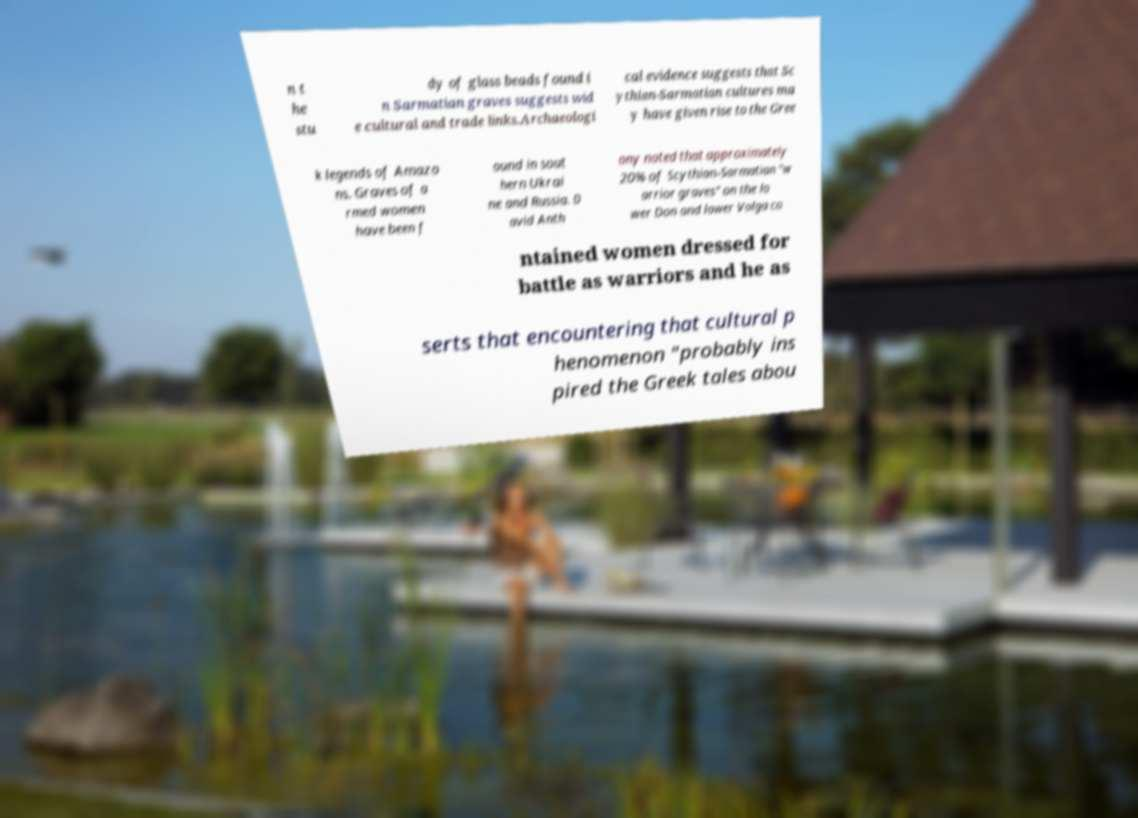There's text embedded in this image that I need extracted. Can you transcribe it verbatim? n t he stu dy of glass beads found i n Sarmatian graves suggests wid e cultural and trade links.Archaeologi cal evidence suggests that Sc ythian-Sarmatian cultures ma y have given rise to the Gree k legends of Amazo ns. Graves of a rmed women have been f ound in sout hern Ukrai ne and Russia. D avid Anth ony noted that approximately 20% of Scythian-Sarmatian "w arrior graves" on the lo wer Don and lower Volga co ntained women dressed for battle as warriors and he as serts that encountering that cultural p henomenon "probably ins pired the Greek tales abou 